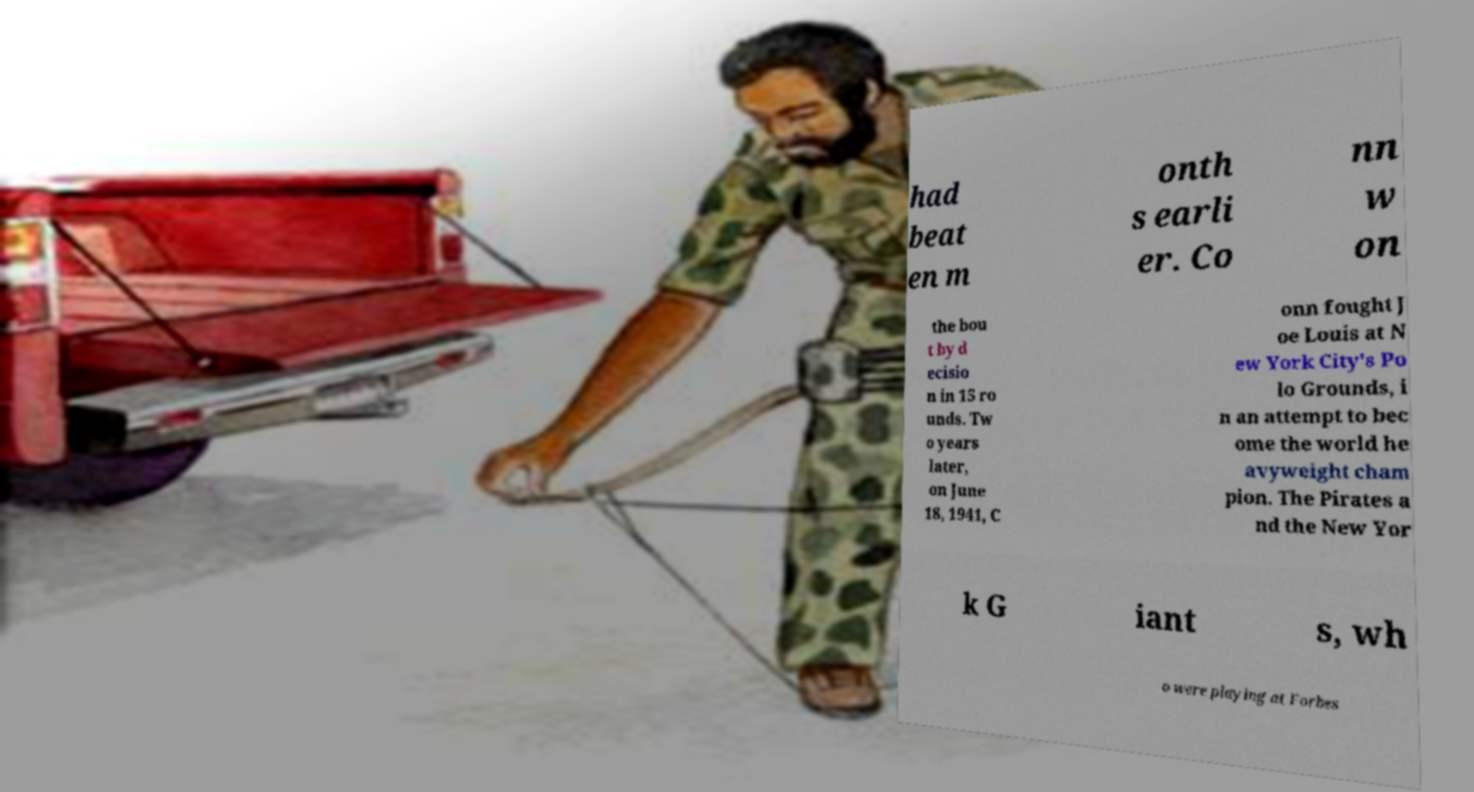For documentation purposes, I need the text within this image transcribed. Could you provide that? had beat en m onth s earli er. Co nn w on the bou t by d ecisio n in 15 ro unds. Tw o years later, on June 18, 1941, C onn fought J oe Louis at N ew York City's Po lo Grounds, i n an attempt to bec ome the world he avyweight cham pion. The Pirates a nd the New Yor k G iant s, wh o were playing at Forbes 